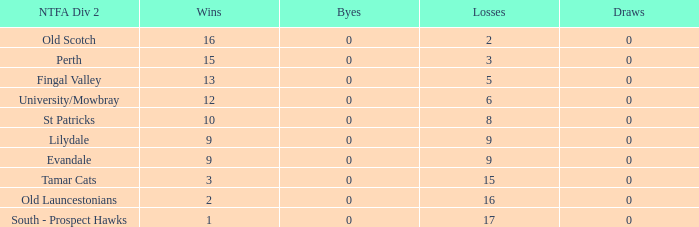What is the lowest number of draws of the team with 9 wins and less than 0 byes? None. 